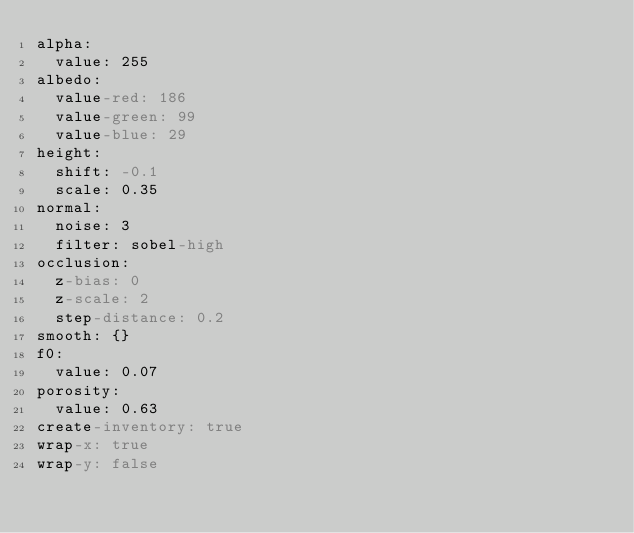Convert code to text. <code><loc_0><loc_0><loc_500><loc_500><_YAML_>alpha:
  value: 255
albedo:
  value-red: 186
  value-green: 99
  value-blue: 29
height:
  shift: -0.1
  scale: 0.35
normal:
  noise: 3
  filter: sobel-high
occlusion:
  z-bias: 0
  z-scale: 2
  step-distance: 0.2
smooth: {}
f0:
  value: 0.07
porosity:
  value: 0.63
create-inventory: true
wrap-x: true
wrap-y: false
</code> 